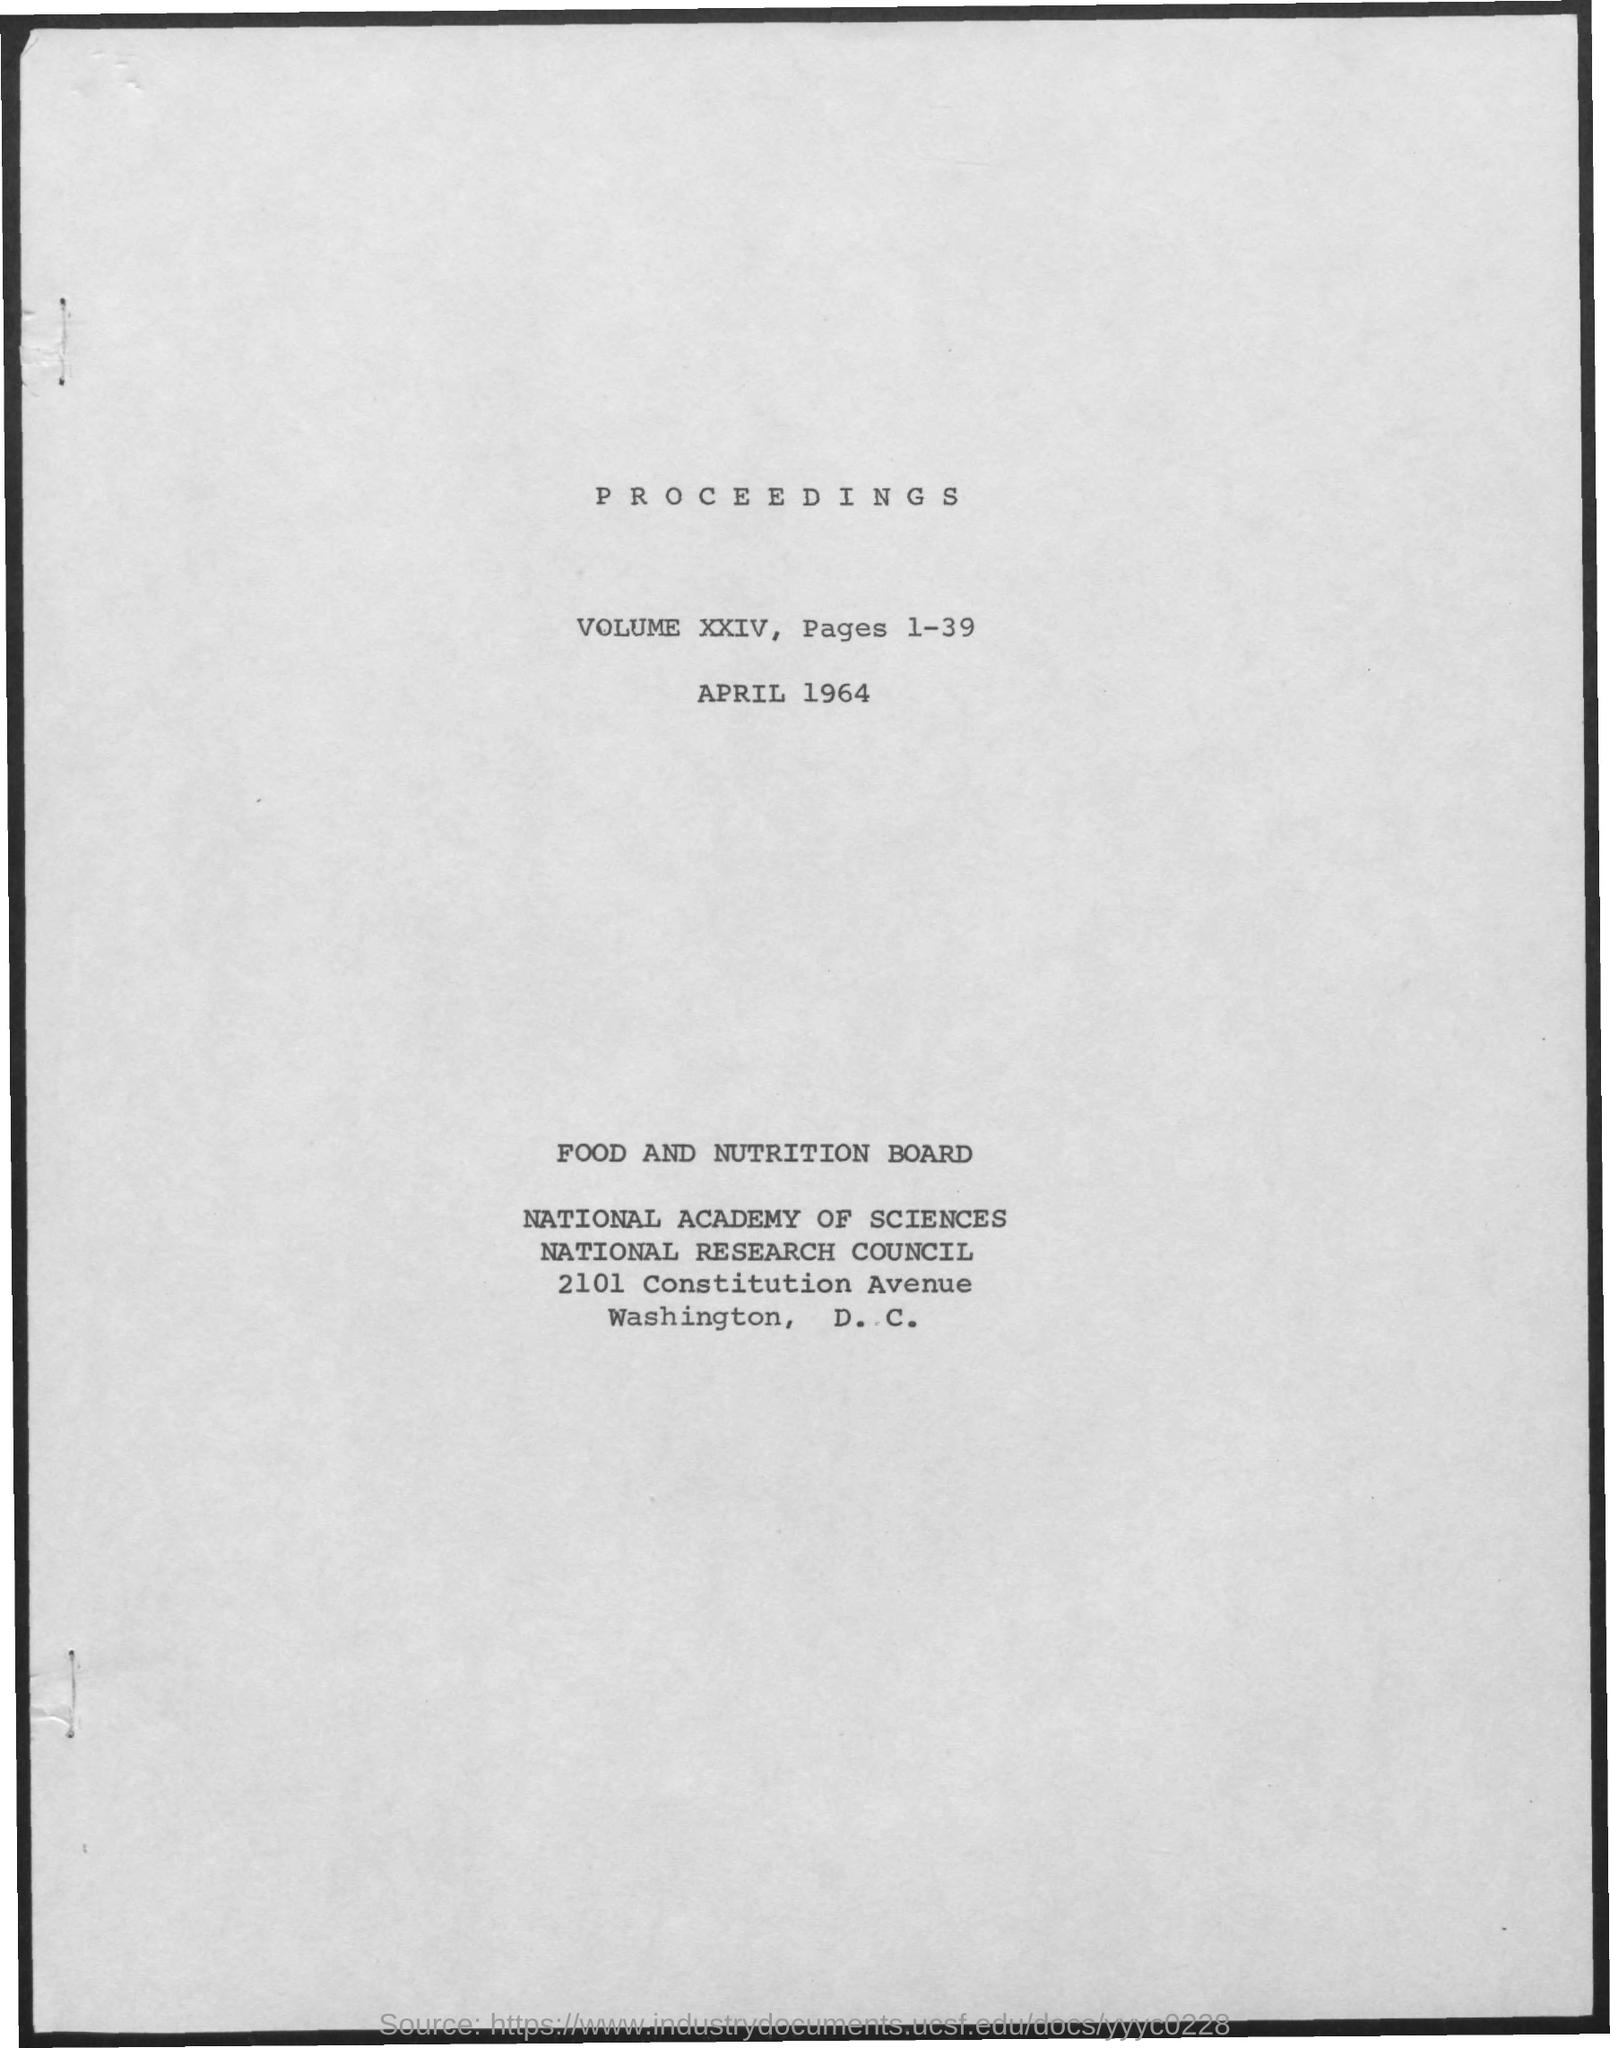Mention a couple of crucial points in this snapshot. I, [Your Name], declare that the title of this document is "Proceedings..". The date is April 1964. The volume is XXIV. There are 39 pages in total. 